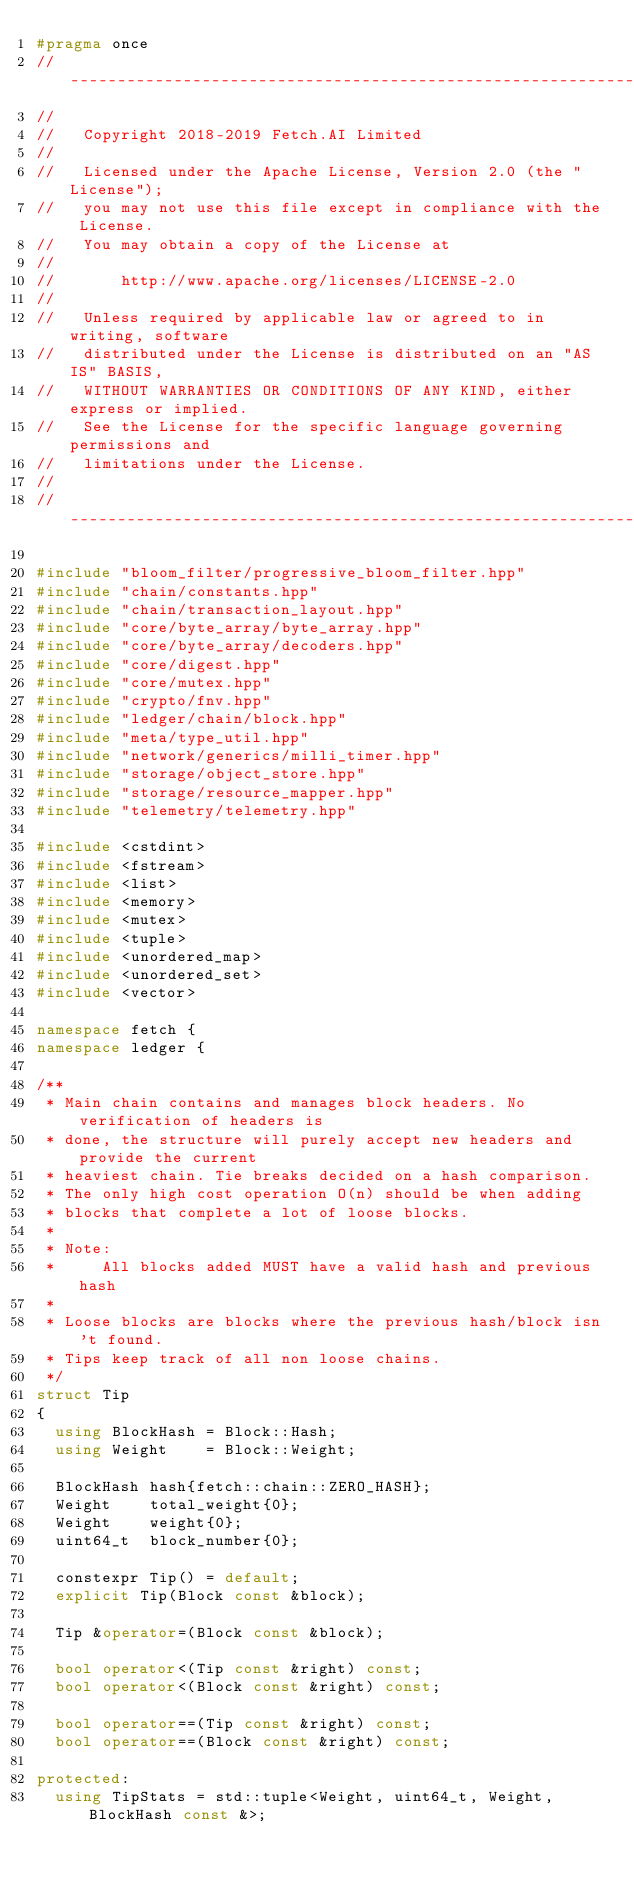<code> <loc_0><loc_0><loc_500><loc_500><_C++_>#pragma once
//------------------------------------------------------------------------------
//
//   Copyright 2018-2019 Fetch.AI Limited
//
//   Licensed under the Apache License, Version 2.0 (the "License");
//   you may not use this file except in compliance with the License.
//   You may obtain a copy of the License at
//
//       http://www.apache.org/licenses/LICENSE-2.0
//
//   Unless required by applicable law or agreed to in writing, software
//   distributed under the License is distributed on an "AS IS" BASIS,
//   WITHOUT WARRANTIES OR CONDITIONS OF ANY KIND, either express or implied.
//   See the License for the specific language governing permissions and
//   limitations under the License.
//
//------------------------------------------------------------------------------

#include "bloom_filter/progressive_bloom_filter.hpp"
#include "chain/constants.hpp"
#include "chain/transaction_layout.hpp"
#include "core/byte_array/byte_array.hpp"
#include "core/byte_array/decoders.hpp"
#include "core/digest.hpp"
#include "core/mutex.hpp"
#include "crypto/fnv.hpp"
#include "ledger/chain/block.hpp"
#include "meta/type_util.hpp"
#include "network/generics/milli_timer.hpp"
#include "storage/object_store.hpp"
#include "storage/resource_mapper.hpp"
#include "telemetry/telemetry.hpp"

#include <cstdint>
#include <fstream>
#include <list>
#include <memory>
#include <mutex>
#include <tuple>
#include <unordered_map>
#include <unordered_set>
#include <vector>

namespace fetch {
namespace ledger {

/**
 * Main chain contains and manages block headers. No verification of headers is
 * done, the structure will purely accept new headers and provide the current
 * heaviest chain. Tie breaks decided on a hash comparison.
 * The only high cost operation O(n) should be when adding
 * blocks that complete a lot of loose blocks.
 *
 * Note:
 *     All blocks added MUST have a valid hash and previous hash
 *
 * Loose blocks are blocks where the previous hash/block isn't found.
 * Tips keep track of all non loose chains.
 */
struct Tip
{
  using BlockHash = Block::Hash;
  using Weight    = Block::Weight;

  BlockHash hash{fetch::chain::ZERO_HASH};
  Weight    total_weight{0};
  Weight    weight{0};
  uint64_t  block_number{0};

  constexpr Tip() = default;
  explicit Tip(Block const &block);

  Tip &operator=(Block const &block);

  bool operator<(Tip const &right) const;
  bool operator<(Block const &right) const;

  bool operator==(Tip const &right) const;
  bool operator==(Block const &right) const;

protected:
  using TipStats = std::tuple<Weight, uint64_t, Weight, BlockHash const &>;</code> 